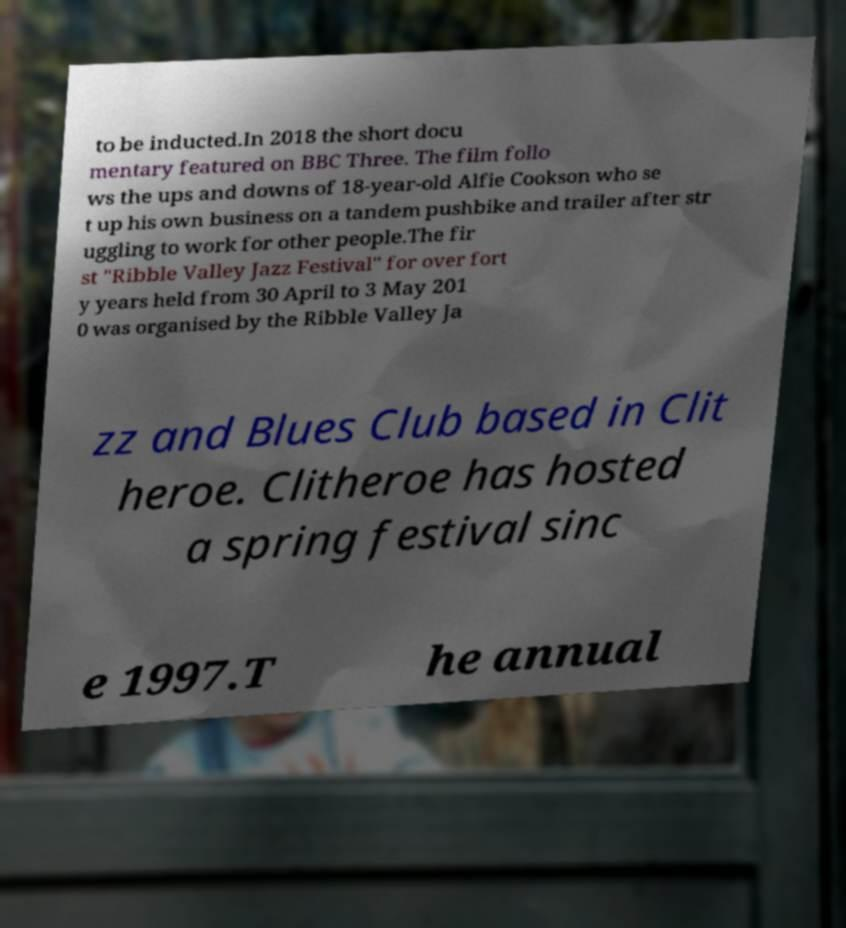I need the written content from this picture converted into text. Can you do that? to be inducted.In 2018 the short docu mentary featured on BBC Three. The film follo ws the ups and downs of 18-year-old Alfie Cookson who se t up his own business on a tandem pushbike and trailer after str uggling to work for other people.The fir st "Ribble Valley Jazz Festival" for over fort y years held from 30 April to 3 May 201 0 was organised by the Ribble Valley Ja zz and Blues Club based in Clit heroe. Clitheroe has hosted a spring festival sinc e 1997.T he annual 